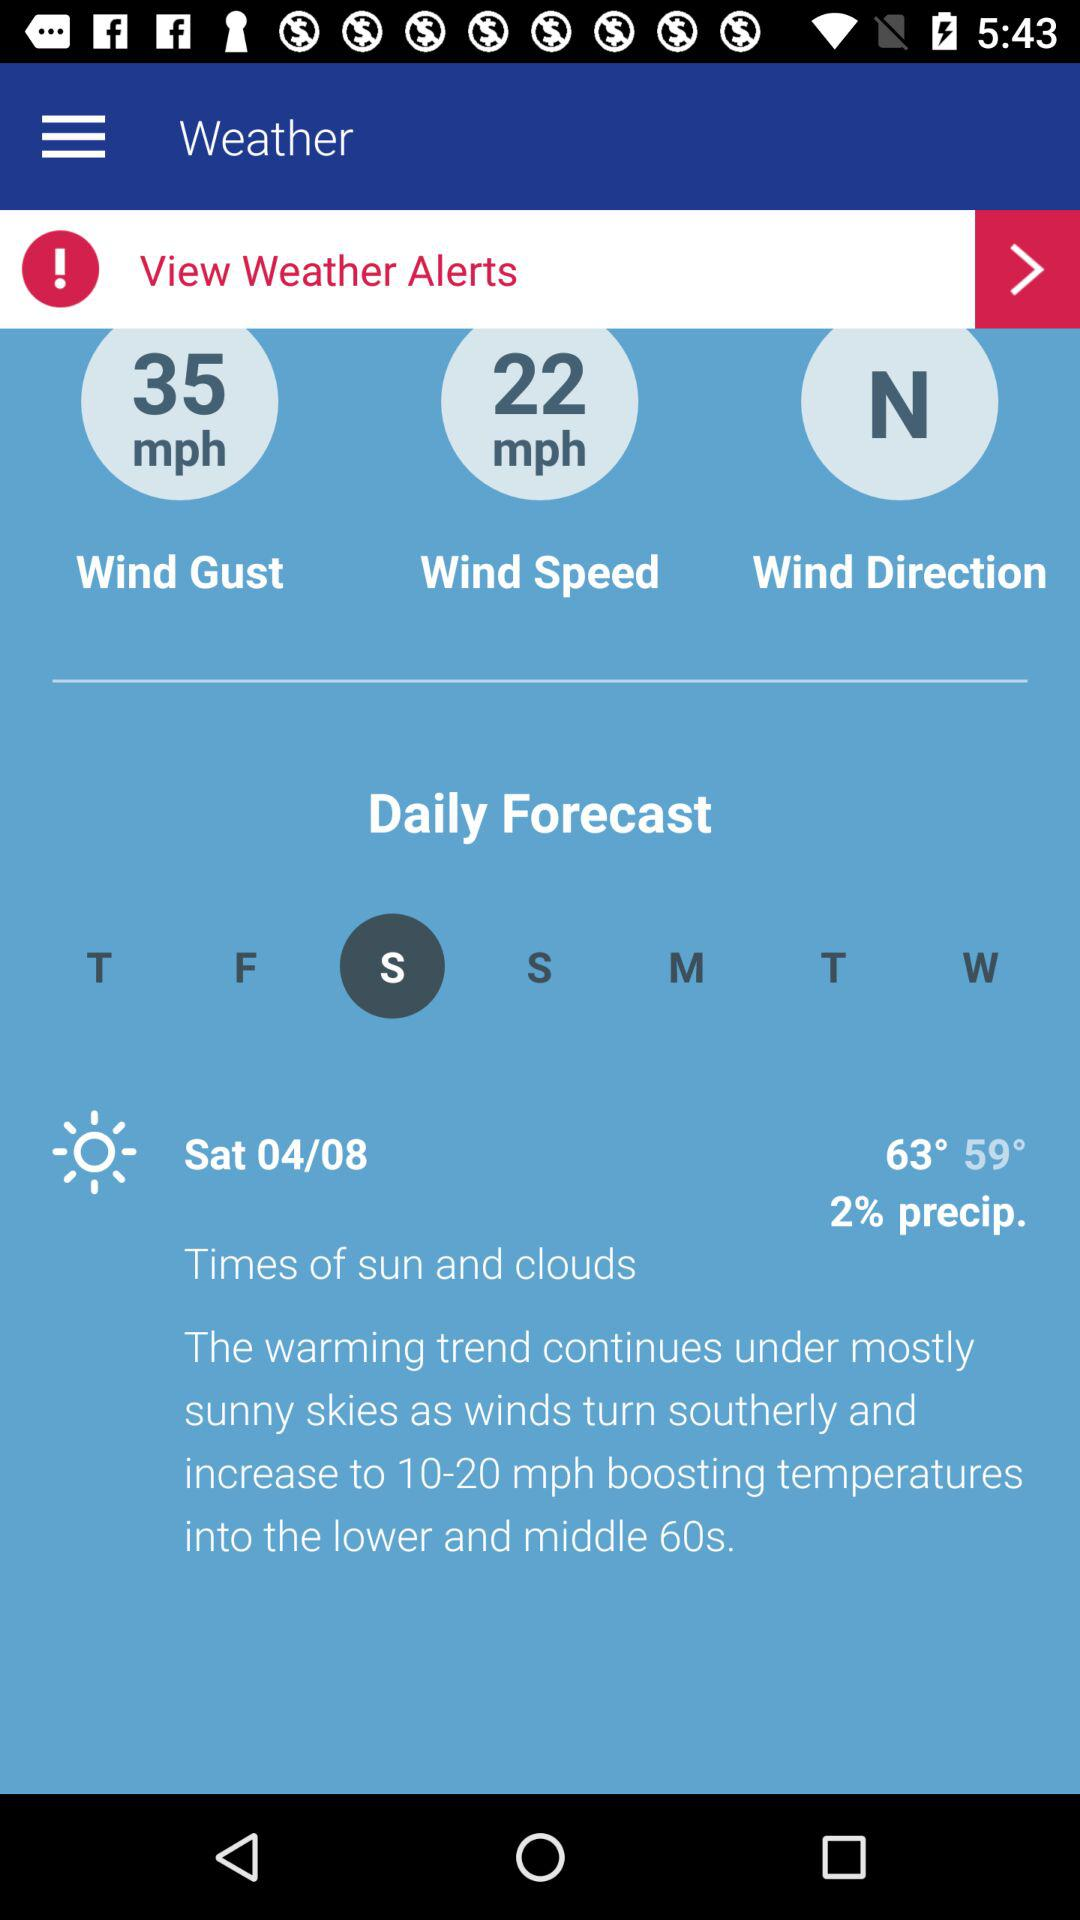What is the wind gust? The wind gust is 35 mph. 